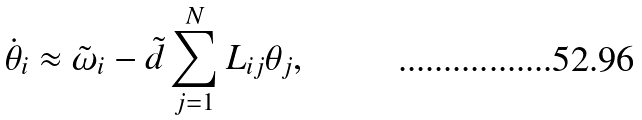Convert formula to latex. <formula><loc_0><loc_0><loc_500><loc_500>\dot { \theta } _ { i } \approx \tilde { \omega } _ { i } - \tilde { d } \sum _ { j = 1 } ^ { N } L _ { i j } \theta _ { j } ,</formula> 